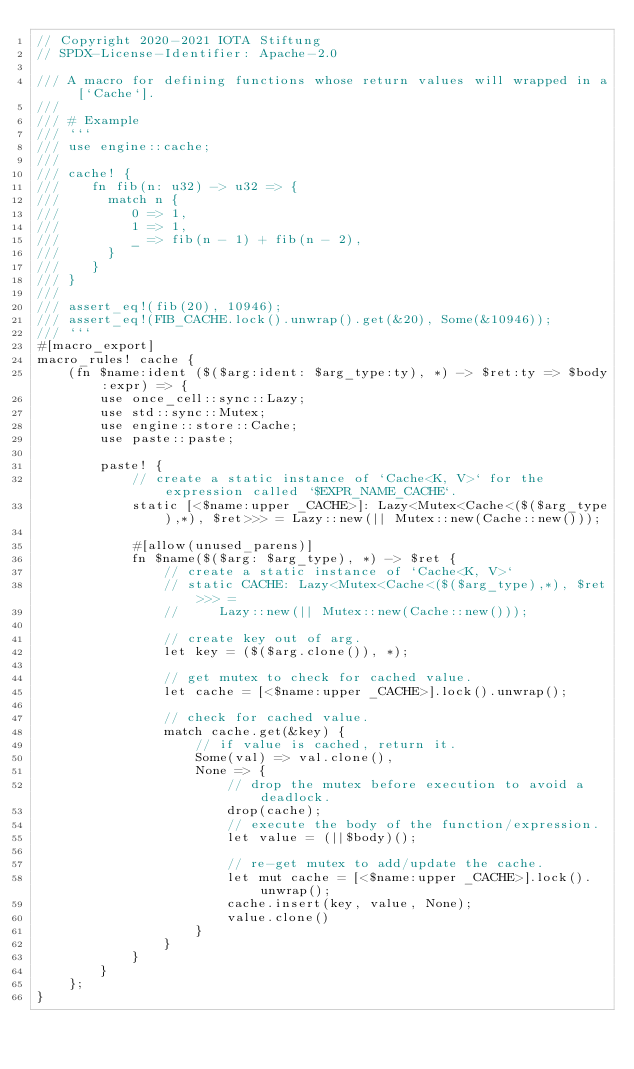Convert code to text. <code><loc_0><loc_0><loc_500><loc_500><_Rust_>// Copyright 2020-2021 IOTA Stiftung
// SPDX-License-Identifier: Apache-2.0

/// A macro for defining functions whose return values will wrapped in a [`Cache`].
///
/// # Example
/// ```
/// use engine::cache;
///
/// cache! {
///    fn fib(n: u32) -> u32 => {
///      match n {
///         0 => 1,
///         1 => 1,
///         _ => fib(n - 1) + fib(n - 2),
///      }
///    }
/// }
///
/// assert_eq!(fib(20), 10946);
/// assert_eq!(FIB_CACHE.lock().unwrap().get(&20), Some(&10946));
/// ```
#[macro_export]
macro_rules! cache {
    (fn $name:ident ($($arg:ident: $arg_type:ty), *) -> $ret:ty => $body:expr) => {
        use once_cell::sync::Lazy;
        use std::sync::Mutex;
        use engine::store::Cache;
        use paste::paste;

        paste! {
            // create a static instance of `Cache<K, V>` for the expression called `$EXPR_NAME_CACHE`.
            static [<$name:upper _CACHE>]: Lazy<Mutex<Cache<($($arg_type),*), $ret>>> = Lazy::new(|| Mutex::new(Cache::new()));

            #[allow(unused_parens)]
            fn $name($($arg: $arg_type), *) -> $ret {
                // create a static instance of `Cache<K, V>`
                // static CACHE: Lazy<Mutex<Cache<($($arg_type),*), $ret>>> =
                //     Lazy::new(|| Mutex::new(Cache::new()));

                // create key out of arg.
                let key = ($($arg.clone()), *);

                // get mutex to check for cached value.
                let cache = [<$name:upper _CACHE>].lock().unwrap();

                // check for cached value.
                match cache.get(&key) {
                    // if value is cached, return it.
                    Some(val) => val.clone(),
                    None => {
                        // drop the mutex before execution to avoid a deadlock.
                        drop(cache);
                        // execute the body of the function/expression.
                        let value = (||$body)();

                        // re-get mutex to add/update the cache.
                        let mut cache = [<$name:upper _CACHE>].lock().unwrap();
                        cache.insert(key, value, None);
                        value.clone()
                    }
                }
            }
        }
    };
}
</code> 